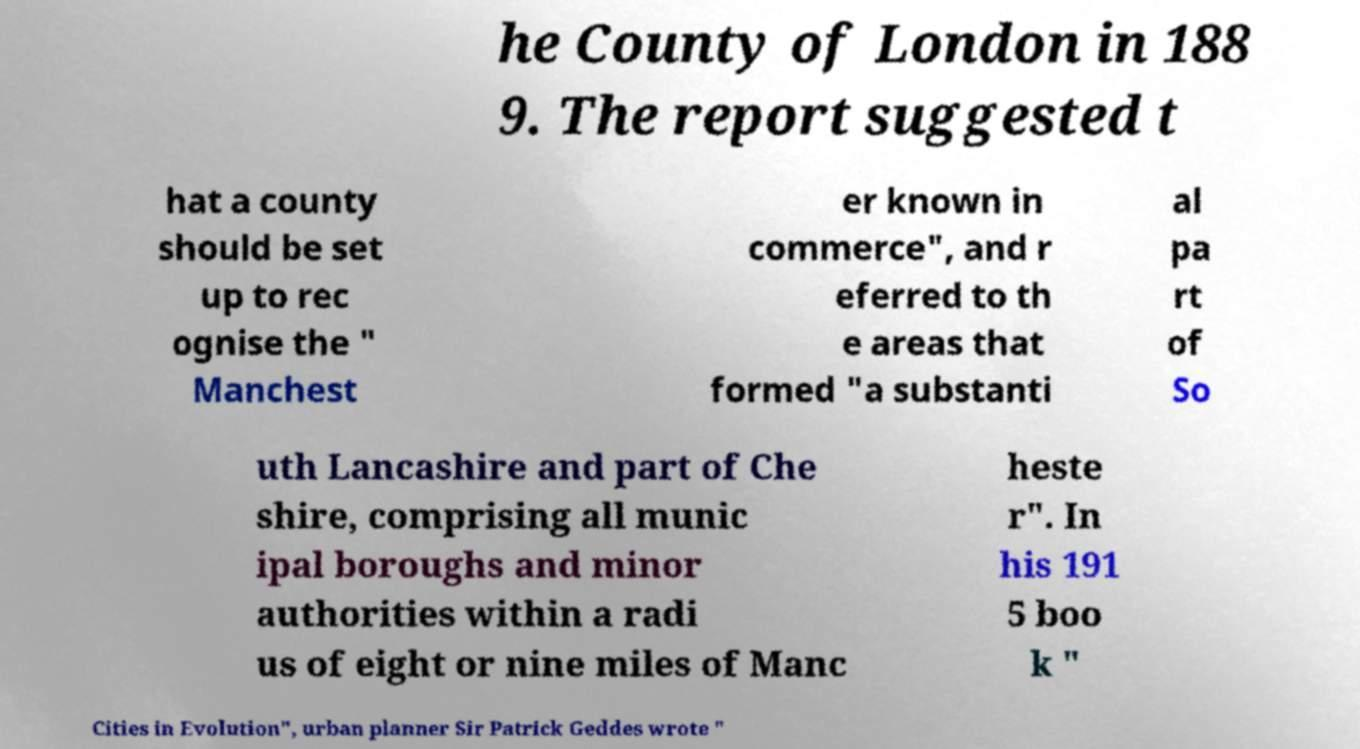Can you read and provide the text displayed in the image?This photo seems to have some interesting text. Can you extract and type it out for me? he County of London in 188 9. The report suggested t hat a county should be set up to rec ognise the " Manchest er known in commerce", and r eferred to th e areas that formed "a substanti al pa rt of So uth Lancashire and part of Che shire, comprising all munic ipal boroughs and minor authorities within a radi us of eight or nine miles of Manc heste r". In his 191 5 boo k " Cities in Evolution", urban planner Sir Patrick Geddes wrote " 